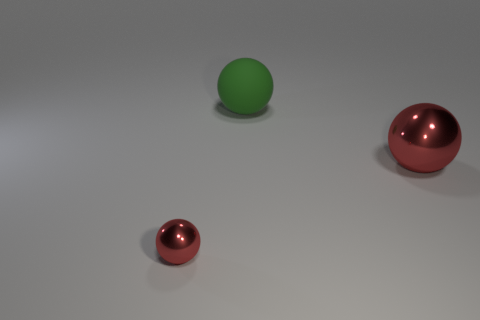Subtract all tiny spheres. How many spheres are left? 2 Subtract all gray blocks. How many red spheres are left? 2 Add 1 yellow shiny cubes. How many objects exist? 4 Subtract all green spheres. How many spheres are left? 2 Subtract 1 spheres. How many spheres are left? 2 Add 3 large cyan matte objects. How many large cyan matte objects exist? 3 Subtract 0 gray spheres. How many objects are left? 3 Subtract all cyan balls. Subtract all purple cubes. How many balls are left? 3 Subtract all large metal balls. Subtract all red balls. How many objects are left? 0 Add 1 big metal balls. How many big metal balls are left? 2 